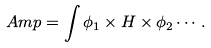<formula> <loc_0><loc_0><loc_500><loc_500>A m p = \int \phi _ { 1 } \times H \times \phi _ { 2 } \cdots \, .</formula> 